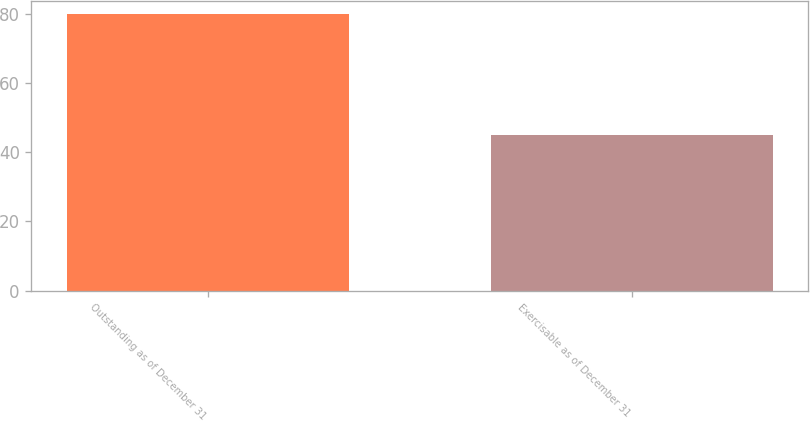Convert chart. <chart><loc_0><loc_0><loc_500><loc_500><bar_chart><fcel>Outstanding as of December 31<fcel>Exercisable as of December 31<nl><fcel>79.8<fcel>44.9<nl></chart> 